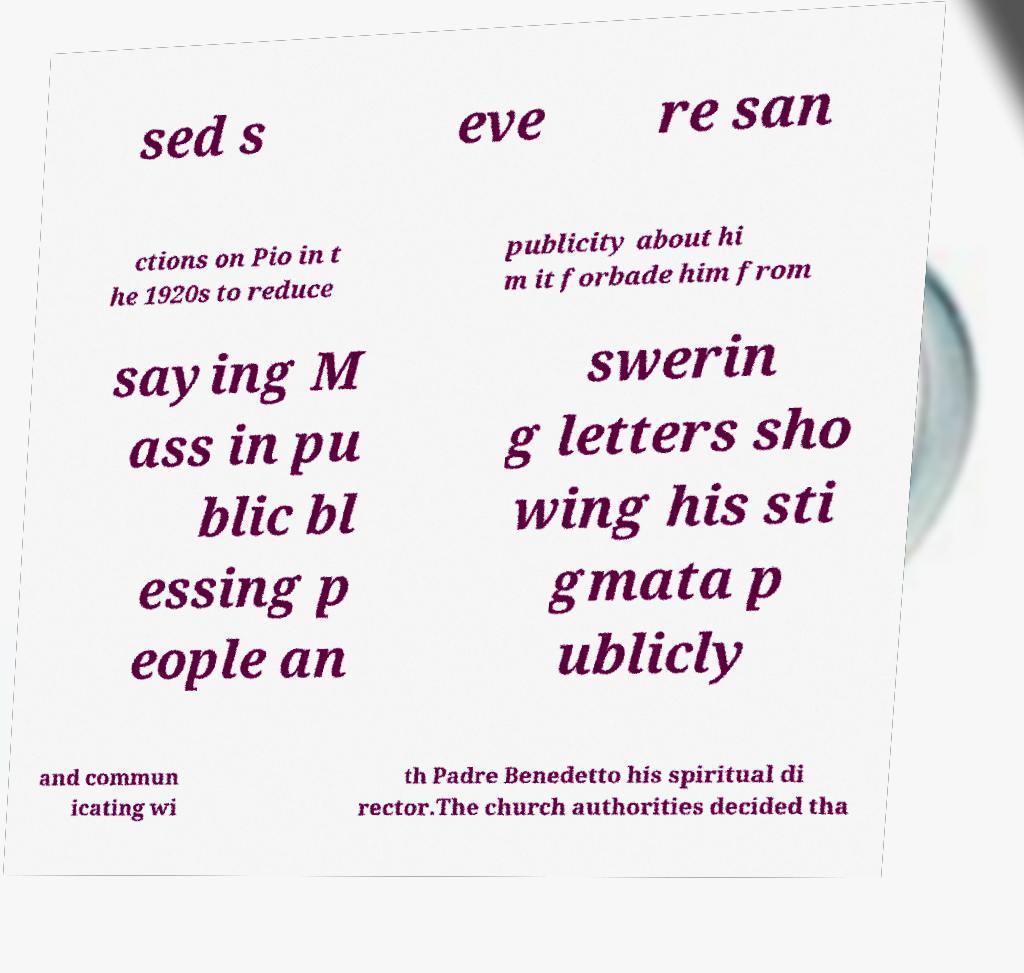Please identify and transcribe the text found in this image. sed s eve re san ctions on Pio in t he 1920s to reduce publicity about hi m it forbade him from saying M ass in pu blic bl essing p eople an swerin g letters sho wing his sti gmata p ublicly and commun icating wi th Padre Benedetto his spiritual di rector.The church authorities decided tha 